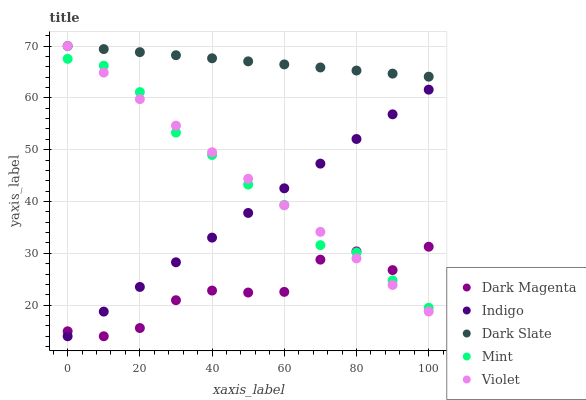Does Dark Magenta have the minimum area under the curve?
Answer yes or no. Yes. Does Dark Slate have the maximum area under the curve?
Answer yes or no. Yes. Does Mint have the minimum area under the curve?
Answer yes or no. No. Does Mint have the maximum area under the curve?
Answer yes or no. No. Is Indigo the smoothest?
Answer yes or no. Yes. Is Dark Magenta the roughest?
Answer yes or no. Yes. Is Mint the smoothest?
Answer yes or no. No. Is Mint the roughest?
Answer yes or no. No. Does Indigo have the lowest value?
Answer yes or no. Yes. Does Mint have the lowest value?
Answer yes or no. No. Does Violet have the highest value?
Answer yes or no. Yes. Does Mint have the highest value?
Answer yes or no. No. Is Dark Magenta less than Dark Slate?
Answer yes or no. Yes. Is Dark Slate greater than Mint?
Answer yes or no. Yes. Does Indigo intersect Violet?
Answer yes or no. Yes. Is Indigo less than Violet?
Answer yes or no. No. Is Indigo greater than Violet?
Answer yes or no. No. Does Dark Magenta intersect Dark Slate?
Answer yes or no. No. 